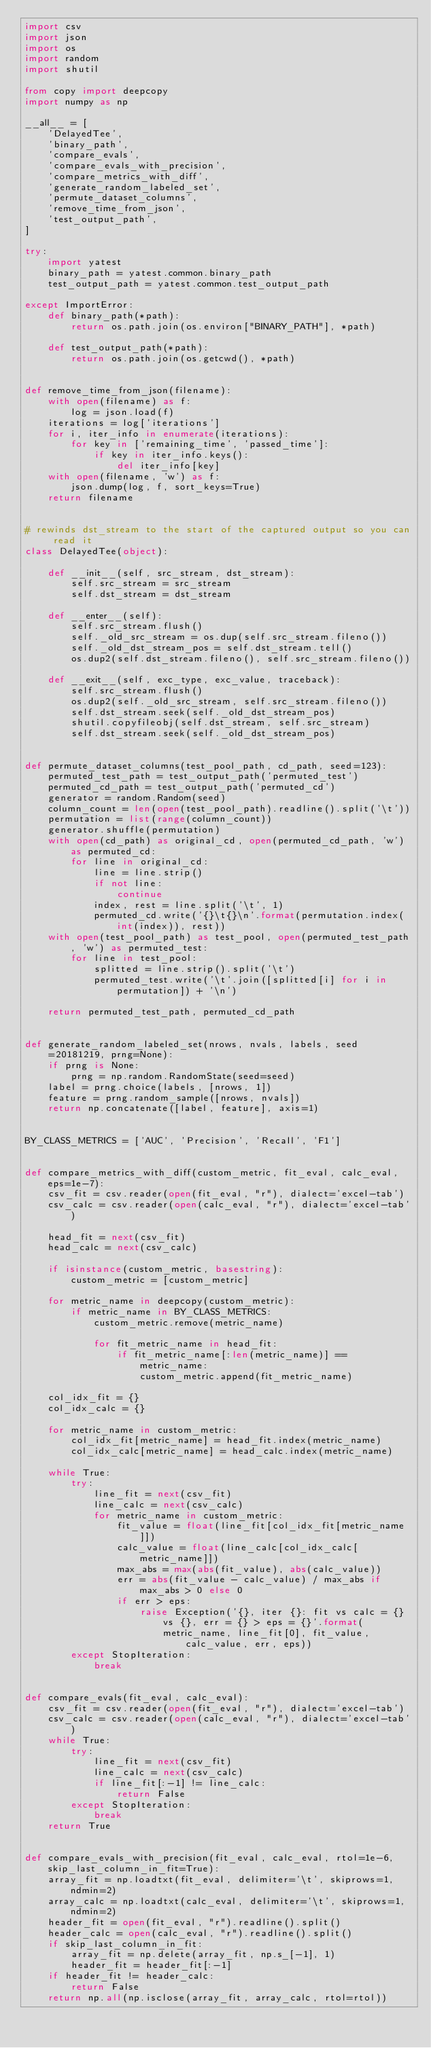Convert code to text. <code><loc_0><loc_0><loc_500><loc_500><_Python_>import csv
import json
import os
import random
import shutil

from copy import deepcopy
import numpy as np

__all__ = [
    'DelayedTee',
    'binary_path',
    'compare_evals',
    'compare_evals_with_precision',
    'compare_metrics_with_diff',
    'generate_random_labeled_set',
    'permute_dataset_columns',
    'remove_time_from_json',
    'test_output_path',
]

try:
    import yatest
    binary_path = yatest.common.binary_path
    test_output_path = yatest.common.test_output_path

except ImportError:
    def binary_path(*path):
        return os.path.join(os.environ["BINARY_PATH"], *path)

    def test_output_path(*path):
        return os.path.join(os.getcwd(), *path)


def remove_time_from_json(filename):
    with open(filename) as f:
        log = json.load(f)
    iterations = log['iterations']
    for i, iter_info in enumerate(iterations):
        for key in ['remaining_time', 'passed_time']:
            if key in iter_info.keys():
                del iter_info[key]
    with open(filename, 'w') as f:
        json.dump(log, f, sort_keys=True)
    return filename


# rewinds dst_stream to the start of the captured output so you can read it
class DelayedTee(object):

    def __init__(self, src_stream, dst_stream):
        self.src_stream = src_stream
        self.dst_stream = dst_stream

    def __enter__(self):
        self.src_stream.flush()
        self._old_src_stream = os.dup(self.src_stream.fileno())
        self._old_dst_stream_pos = self.dst_stream.tell()
        os.dup2(self.dst_stream.fileno(), self.src_stream.fileno())

    def __exit__(self, exc_type, exc_value, traceback):
        self.src_stream.flush()
        os.dup2(self._old_src_stream, self.src_stream.fileno())
        self.dst_stream.seek(self._old_dst_stream_pos)
        shutil.copyfileobj(self.dst_stream, self.src_stream)
        self.dst_stream.seek(self._old_dst_stream_pos)


def permute_dataset_columns(test_pool_path, cd_path, seed=123):
    permuted_test_path = test_output_path('permuted_test')
    permuted_cd_path = test_output_path('permuted_cd')
    generator = random.Random(seed)
    column_count = len(open(test_pool_path).readline().split('\t'))
    permutation = list(range(column_count))
    generator.shuffle(permutation)
    with open(cd_path) as original_cd, open(permuted_cd_path, 'w') as permuted_cd:
        for line in original_cd:
            line = line.strip()
            if not line:
                continue
            index, rest = line.split('\t', 1)
            permuted_cd.write('{}\t{}\n'.format(permutation.index(int(index)), rest))
    with open(test_pool_path) as test_pool, open(permuted_test_path, 'w') as permuted_test:
        for line in test_pool:
            splitted = line.strip().split('\t')
            permuted_test.write('\t'.join([splitted[i] for i in permutation]) + '\n')

    return permuted_test_path, permuted_cd_path


def generate_random_labeled_set(nrows, nvals, labels, seed=20181219, prng=None):
    if prng is None:
        prng = np.random.RandomState(seed=seed)
    label = prng.choice(labels, [nrows, 1])
    feature = prng.random_sample([nrows, nvals])
    return np.concatenate([label, feature], axis=1)


BY_CLASS_METRICS = ['AUC', 'Precision', 'Recall', 'F1']


def compare_metrics_with_diff(custom_metric, fit_eval, calc_eval, eps=1e-7):
    csv_fit = csv.reader(open(fit_eval, "r"), dialect='excel-tab')
    csv_calc = csv.reader(open(calc_eval, "r"), dialect='excel-tab')

    head_fit = next(csv_fit)
    head_calc = next(csv_calc)

    if isinstance(custom_metric, basestring):
        custom_metric = [custom_metric]

    for metric_name in deepcopy(custom_metric):
        if metric_name in BY_CLASS_METRICS:
            custom_metric.remove(metric_name)

            for fit_metric_name in head_fit:
                if fit_metric_name[:len(metric_name)] == metric_name:
                    custom_metric.append(fit_metric_name)

    col_idx_fit = {}
    col_idx_calc = {}

    for metric_name in custom_metric:
        col_idx_fit[metric_name] = head_fit.index(metric_name)
        col_idx_calc[metric_name] = head_calc.index(metric_name)

    while True:
        try:
            line_fit = next(csv_fit)
            line_calc = next(csv_calc)
            for metric_name in custom_metric:
                fit_value = float(line_fit[col_idx_fit[metric_name]])
                calc_value = float(line_calc[col_idx_calc[metric_name]])
                max_abs = max(abs(fit_value), abs(calc_value))
                err = abs(fit_value - calc_value) / max_abs if max_abs > 0 else 0
                if err > eps:
                    raise Exception('{}, iter {}: fit vs calc = {} vs {}, err = {} > eps = {}'.format(
                        metric_name, line_fit[0], fit_value, calc_value, err, eps))
        except StopIteration:
            break


def compare_evals(fit_eval, calc_eval):
    csv_fit = csv.reader(open(fit_eval, "r"), dialect='excel-tab')
    csv_calc = csv.reader(open(calc_eval, "r"), dialect='excel-tab')
    while True:
        try:
            line_fit = next(csv_fit)
            line_calc = next(csv_calc)
            if line_fit[:-1] != line_calc:
                return False
        except StopIteration:
            break
    return True


def compare_evals_with_precision(fit_eval, calc_eval, rtol=1e-6, skip_last_column_in_fit=True):
    array_fit = np.loadtxt(fit_eval, delimiter='\t', skiprows=1, ndmin=2)
    array_calc = np.loadtxt(calc_eval, delimiter='\t', skiprows=1, ndmin=2)
    header_fit = open(fit_eval, "r").readline().split()
    header_calc = open(calc_eval, "r").readline().split()
    if skip_last_column_in_fit:
        array_fit = np.delete(array_fit, np.s_[-1], 1)
        header_fit = header_fit[:-1]
    if header_fit != header_calc:
        return False
    return np.all(np.isclose(array_fit, array_calc, rtol=rtol))
</code> 